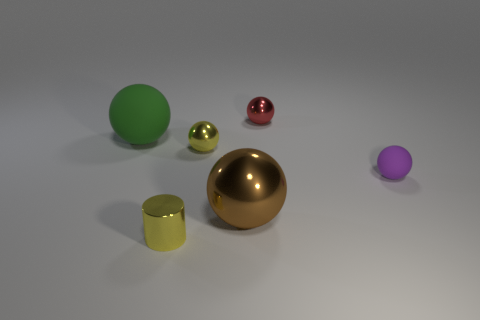How many other things are there of the same shape as the green thing?
Ensure brevity in your answer.  4. Does the object that is to the right of the small red thing have the same material as the green object?
Keep it short and to the point. Yes. How many objects are either yellow cylinders or yellow balls?
Make the answer very short. 2. What size is the brown object that is the same shape as the small purple object?
Your answer should be very brief. Large. What is the size of the purple object?
Your response must be concise. Small. Is the number of tiny yellow shiny spheres to the left of the small yellow ball greater than the number of small purple matte balls?
Offer a very short reply. No. Are there any other things that have the same material as the yellow ball?
Your answer should be compact. Yes. There is a large object that is behind the purple sphere; does it have the same color as the small metal object that is in front of the big brown thing?
Your response must be concise. No. What is the large ball that is right of the large green rubber object behind the small yellow cylinder in front of the red shiny sphere made of?
Your answer should be compact. Metal. Are there more large balls than tiny blue rubber balls?
Keep it short and to the point. Yes. 